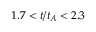<formula> <loc_0><loc_0><loc_500><loc_500>1 . 7 < t / t _ { A } < 2 . 3</formula> 